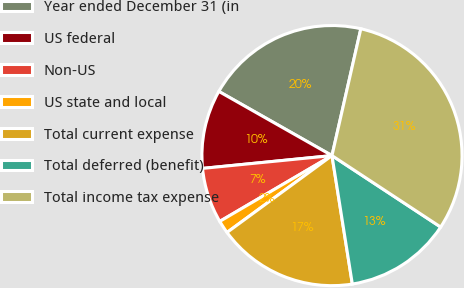<chart> <loc_0><loc_0><loc_500><loc_500><pie_chart><fcel>Year ended December 31 (in<fcel>US federal<fcel>Non-US<fcel>US state and local<fcel>Total current expense<fcel>Total deferred (benefit)<fcel>Total income tax expense<nl><fcel>20.35%<fcel>9.78%<fcel>6.87%<fcel>1.62%<fcel>17.44%<fcel>13.24%<fcel>30.69%<nl></chart> 